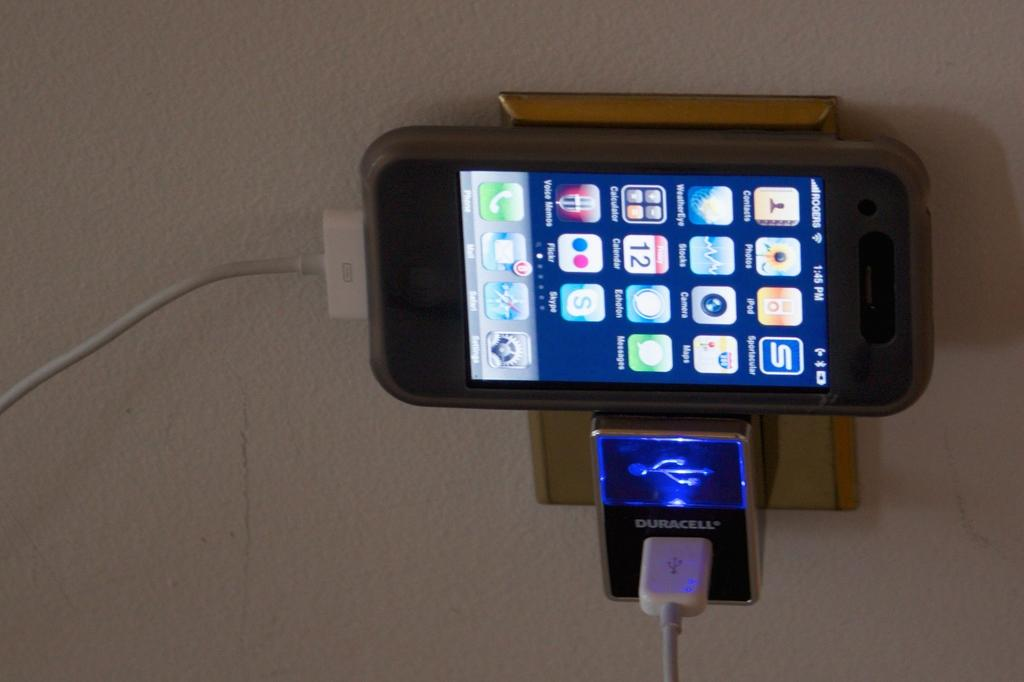Provide a one-sentence caption for the provided image. A cell phone is plugged into a Duracell charger. 